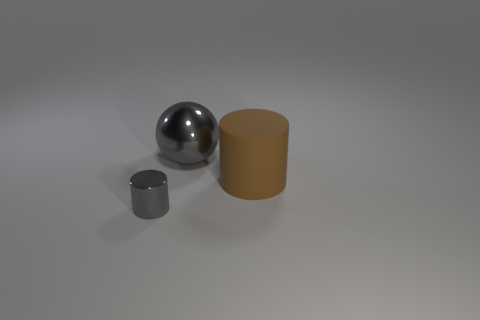There is a metal object that is right of the tiny cylinder; what number of rubber cylinders are behind it?
Ensure brevity in your answer.  0. The cylinder to the right of the gray metal object behind the large rubber cylinder is what color?
Keep it short and to the point. Brown. There is a thing that is behind the tiny cylinder and in front of the big gray thing; what is its material?
Make the answer very short. Rubber. Is there another small metal thing of the same shape as the small metallic thing?
Offer a very short reply. No. Is the shape of the shiny thing that is in front of the sphere the same as  the large rubber object?
Offer a very short reply. Yes. What number of objects are behind the gray metallic cylinder and to the left of the brown object?
Offer a terse response. 1. What shape is the metallic object behind the big cylinder?
Keep it short and to the point. Sphere. What number of large objects have the same material as the tiny gray object?
Provide a succinct answer. 1. There is a tiny gray thing; does it have the same shape as the large object that is on the right side of the metallic sphere?
Provide a succinct answer. Yes. Are there any large gray metal spheres on the left side of the gray object to the right of the gray object on the left side of the big gray metal object?
Your response must be concise. No. 